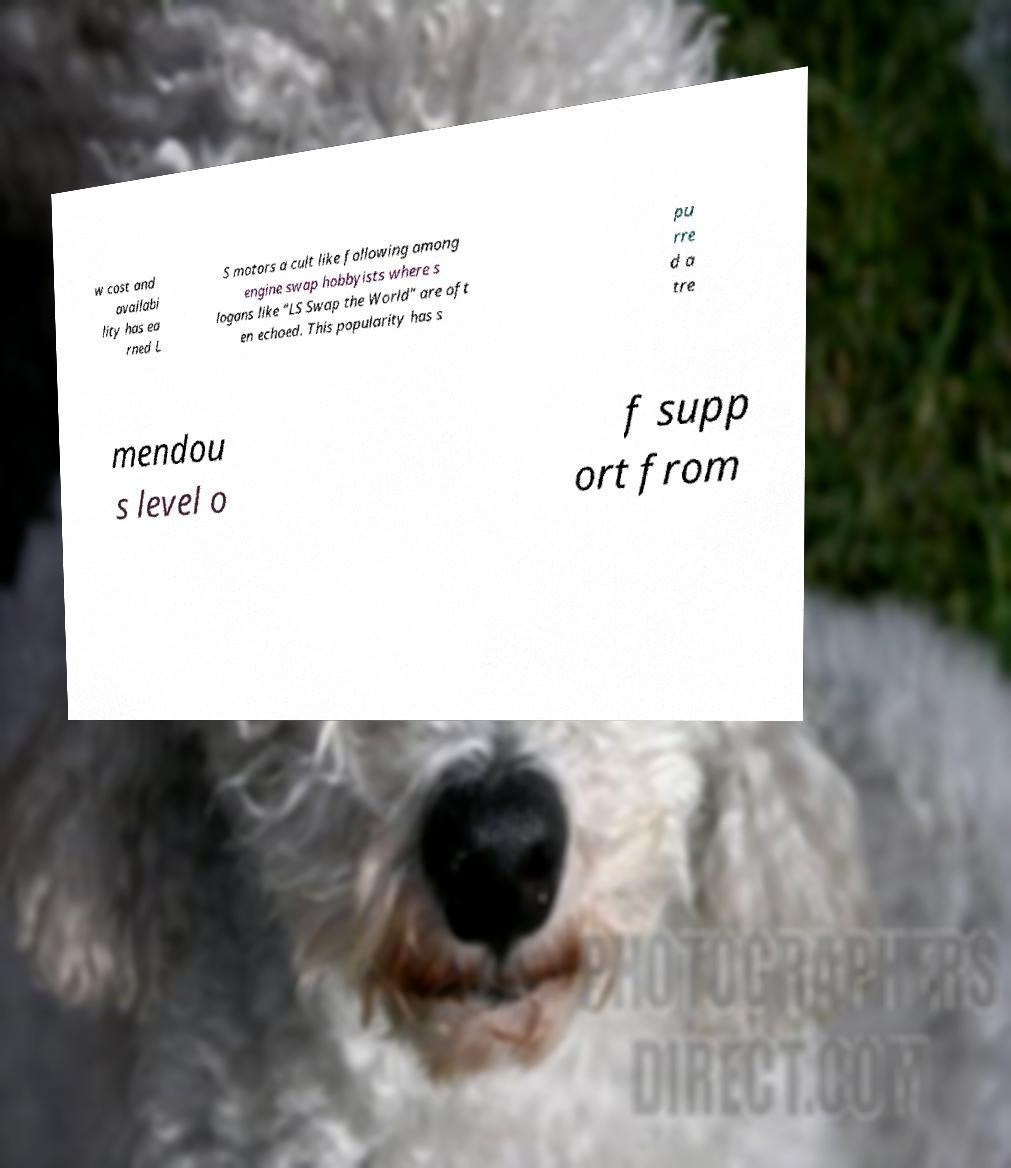There's text embedded in this image that I need extracted. Can you transcribe it verbatim? w cost and availabi lity has ea rned L S motors a cult like following among engine swap hobbyists where s logans like "LS Swap the World" are oft en echoed. This popularity has s pu rre d a tre mendou s level o f supp ort from 